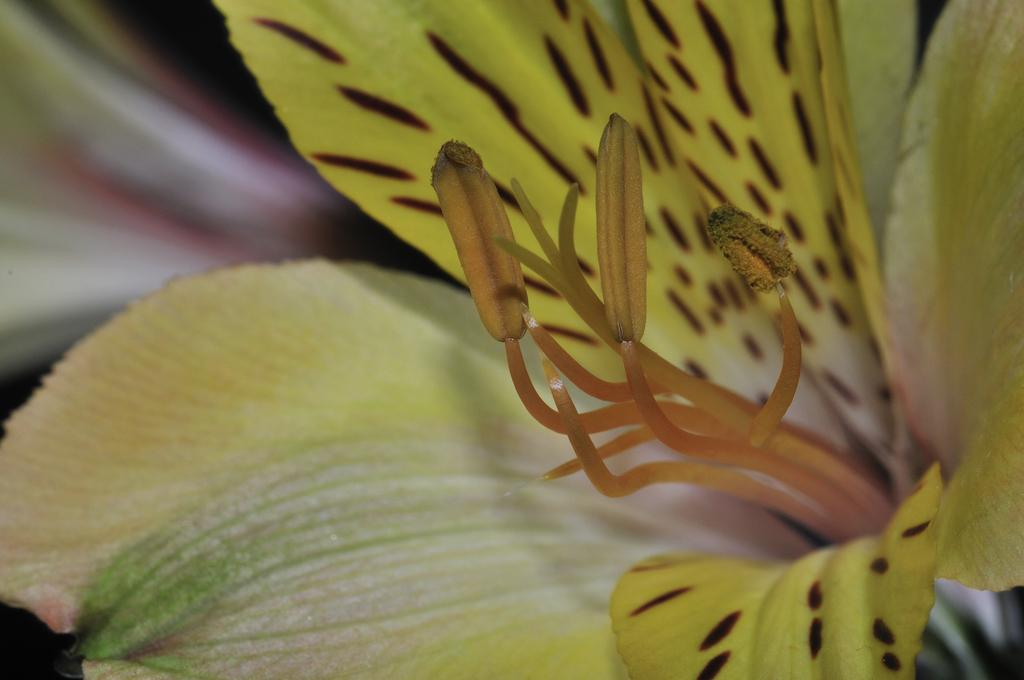What is the main subject of the image? There is a flower in the image. Can you describe the colors of the flower? The flower has yellow, orange, and maroon colors. How would you describe the background of the image? The background of the image is blurry. What type of garden can be seen in the background of the image? There is no garden visible in the image; the background is blurry. What selection of flowers can be seen in the image? The image only features one flower, so there is no selection of flowers to describe. 